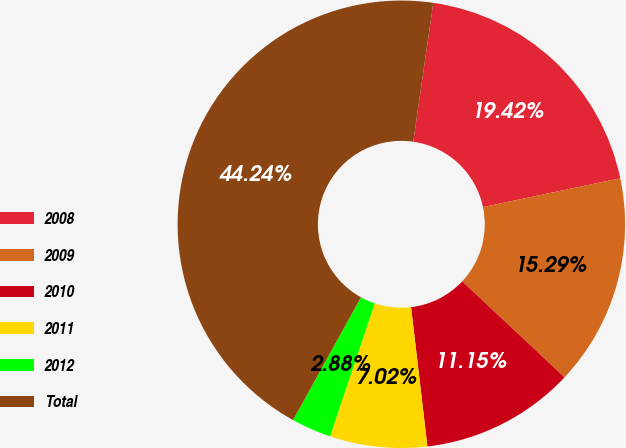Convert chart. <chart><loc_0><loc_0><loc_500><loc_500><pie_chart><fcel>2008<fcel>2009<fcel>2010<fcel>2011<fcel>2012<fcel>Total<nl><fcel>19.42%<fcel>15.29%<fcel>11.15%<fcel>7.02%<fcel>2.88%<fcel>44.24%<nl></chart> 